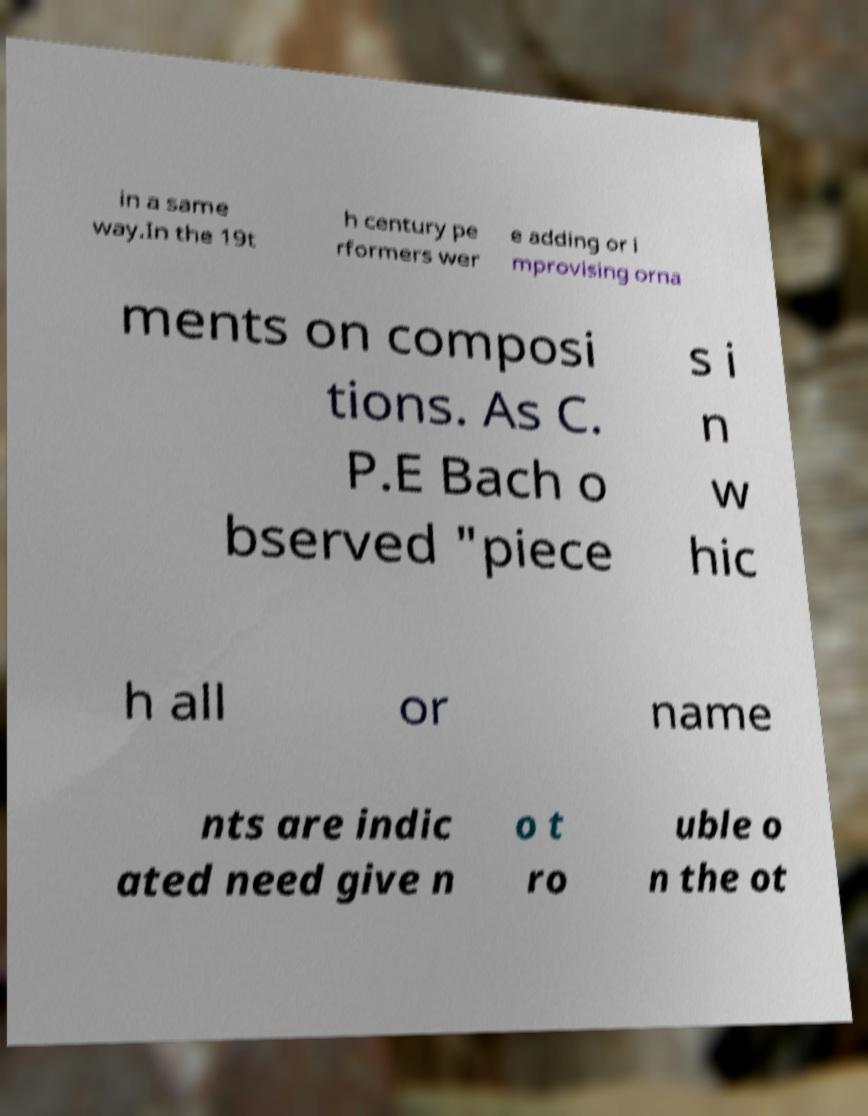Can you accurately transcribe the text from the provided image for me? in a same way.In the 19t h century pe rformers wer e adding or i mprovising orna ments on composi tions. As C. P.E Bach o bserved "piece s i n w hic h all or name nts are indic ated need give n o t ro uble o n the ot 